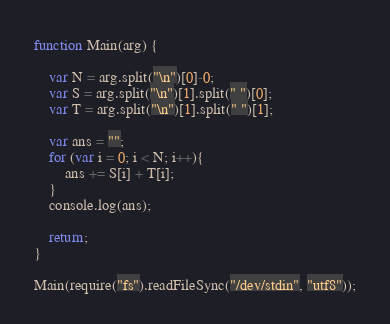Convert code to text. <code><loc_0><loc_0><loc_500><loc_500><_JavaScript_>function Main(arg) {
 
    var N = arg.split("\n")[0]-0;
    var S = arg.split("\n")[1].split(" ")[0];
    var T = arg.split("\n")[1].split(" ")[1];

    var ans = "";
    for (var i = 0; i < N; i++){
        ans += S[i] + T[i];
    }
    console.log(ans);

    return;
}

Main(require("fs").readFileSync("/dev/stdin", "utf8"));</code> 